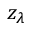Convert formula to latex. <formula><loc_0><loc_0><loc_500><loc_500>z _ { \lambda }</formula> 